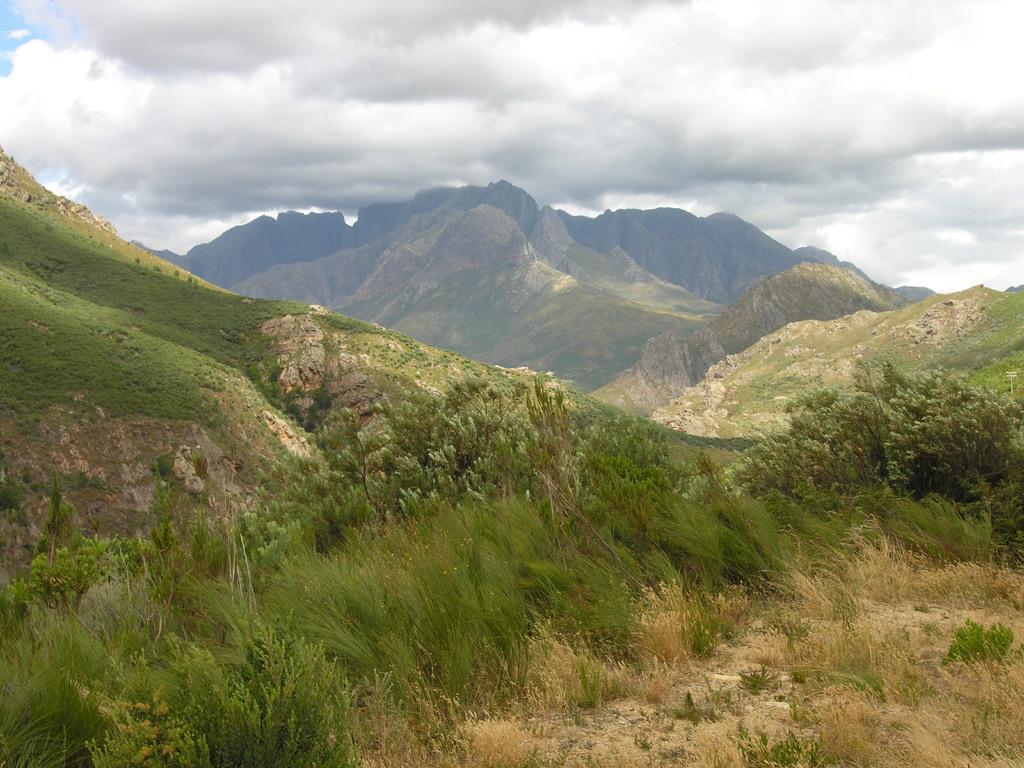How would you summarize this image in a sentence or two? In this image, I can see the mountains. This is the grass. These are the trees. I can see the clouds in the sky. 